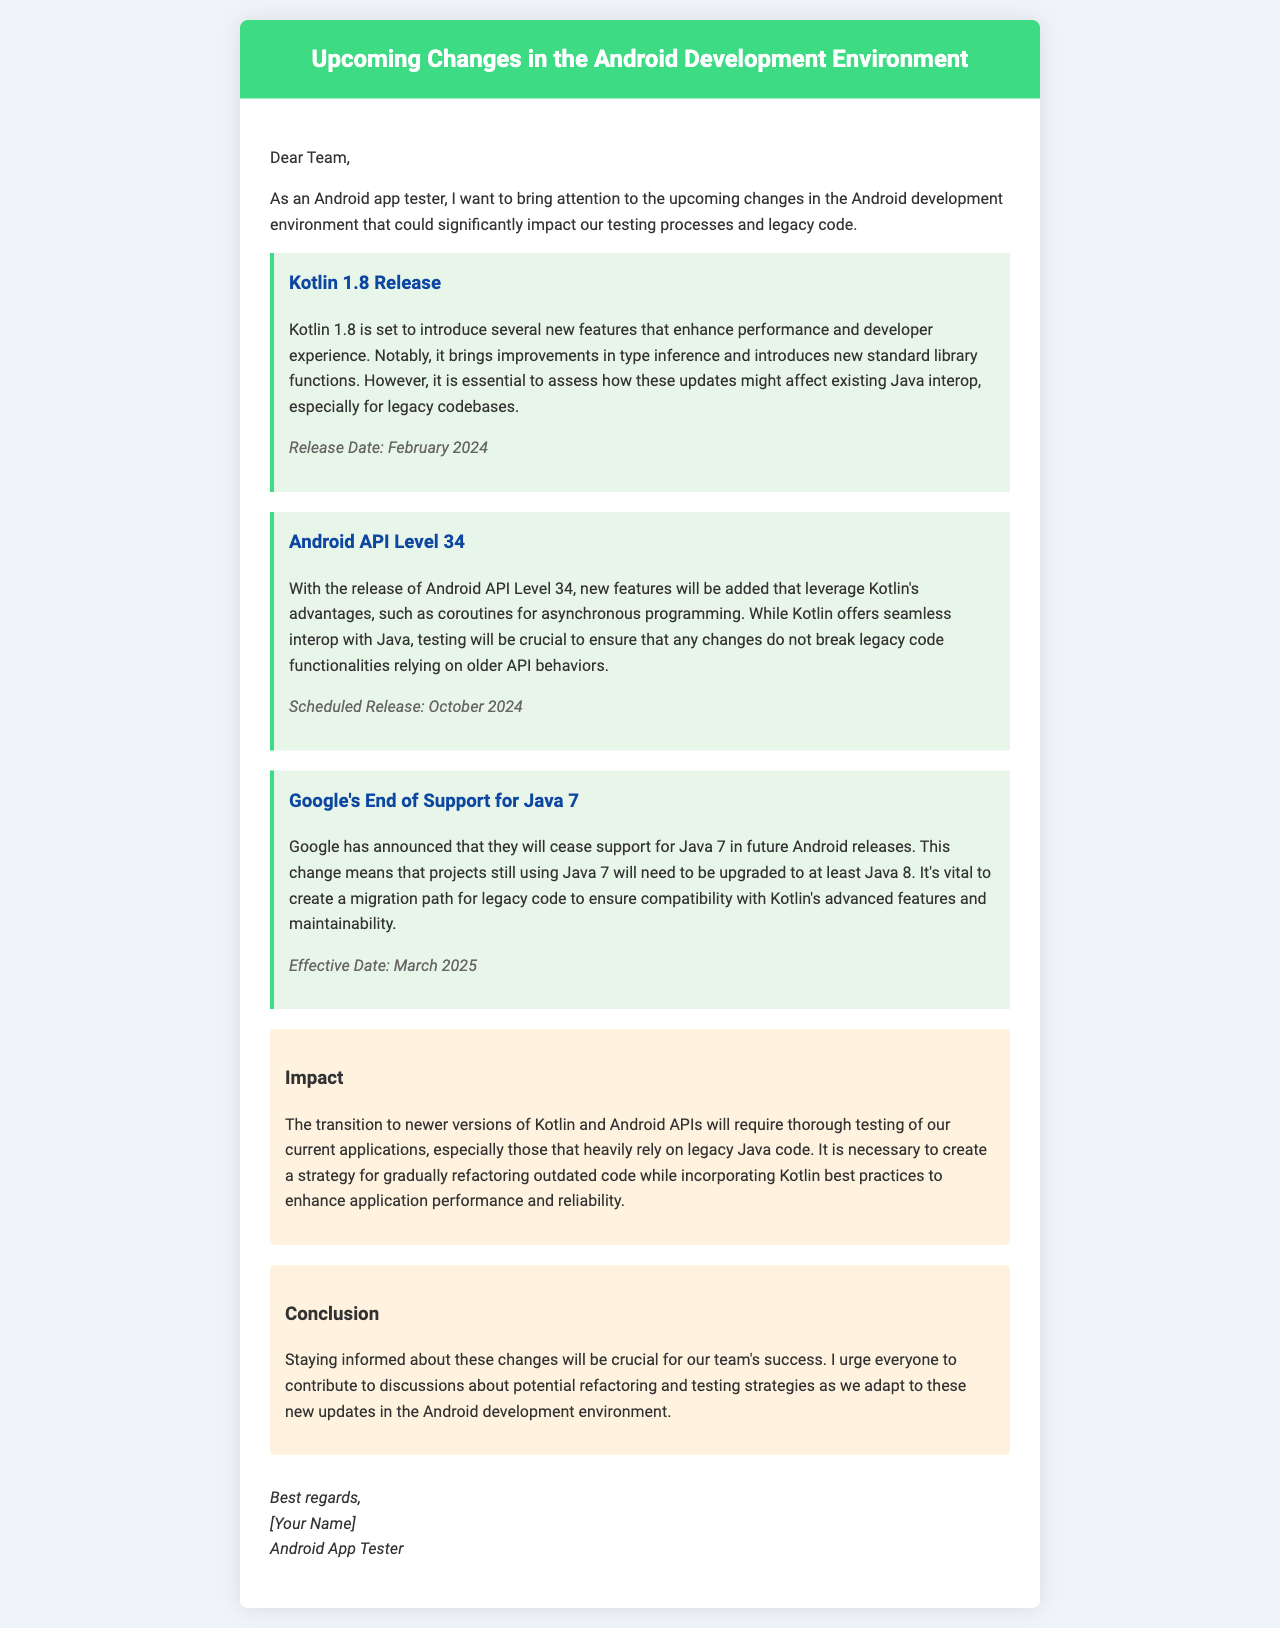What is the release date of Kotlin 1.8? The document states that Kotlin 1.8 is set to be released in February 2024.
Answer: February 2024 What will Google cease support for in future Android releases? The document mentions that Google will cease support for Java 7.
Answer: Java 7 What new Android API level is scheduled for release in October 2024? The document specifically mentions the release of Android API Level 34.
Answer: Android API Level 34 What is the effective date to upgrade from Java 7 to at least Java 8? The document indicates that the effective date is March 2025.
Answer: March 2025 What type of programming does Kotlin's advantages leverage in API Level 34? The document states that Kotlin's advantages leverage coroutines for asynchronous programming.
Answer: Coroutines What will require thorough testing according to the impact section? The impact section mentions that the transition to newer versions of Kotlin and Android APIs will require thorough testing of current applications.
Answer: Current applications Who is the author of the letter? The document indicates that the author signs off as "[Your Name]".
Answer: [Your Name] What is the primary purpose of the letter? The document explains that the primary purpose is to bring attention to upcoming changes in the Android development environment.
Answer: Upcoming changes in the Android development environment 